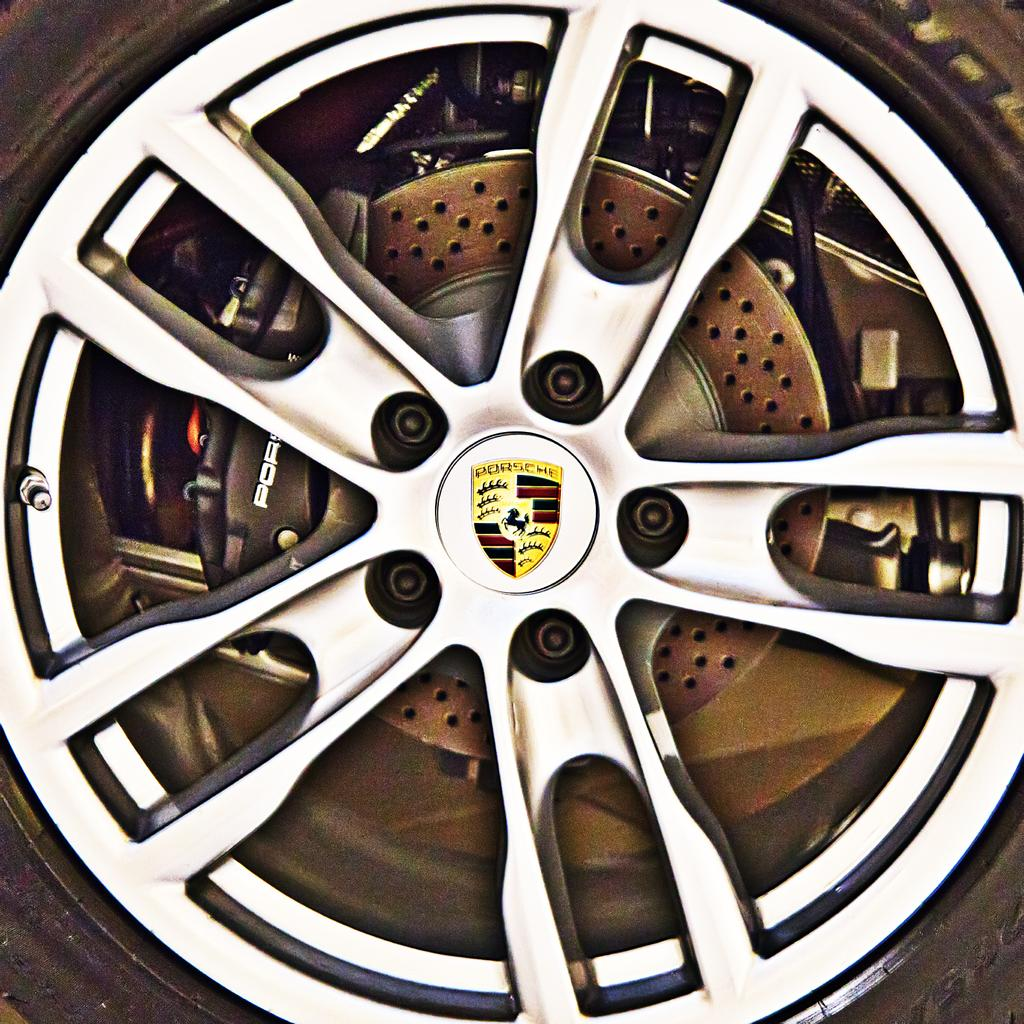What is the main subject of the image? The main subject of the image is a picture of a wheel. What else can be seen in the image besides the wheel? There is a tire visible in the image. What brand is associated with the image? The logo of Porsche is present on the wall in the image. What type of frame is used to hang the sheet in the image? There is no sheet or frame present in the image; it features a picture of a wheel and a tire with the Porsche logo on the wall. 